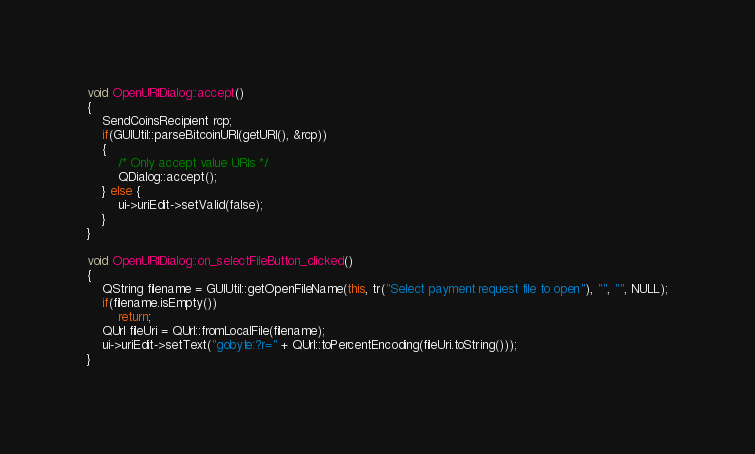Convert code to text. <code><loc_0><loc_0><loc_500><loc_500><_C++_>
void OpenURIDialog::accept()
{
    SendCoinsRecipient rcp;
    if(GUIUtil::parseBitcoinURI(getURI(), &rcp))
    {
        /* Only accept value URIs */
        QDialog::accept();
    } else {
        ui->uriEdit->setValid(false);
    }
}

void OpenURIDialog::on_selectFileButton_clicked()
{
    QString filename = GUIUtil::getOpenFileName(this, tr("Select payment request file to open"), "", "", NULL);
    if(filename.isEmpty())
        return;
    QUrl fileUri = QUrl::fromLocalFile(filename);
    ui->uriEdit->setText("gobyte:?r=" + QUrl::toPercentEncoding(fileUri.toString()));
}
</code> 